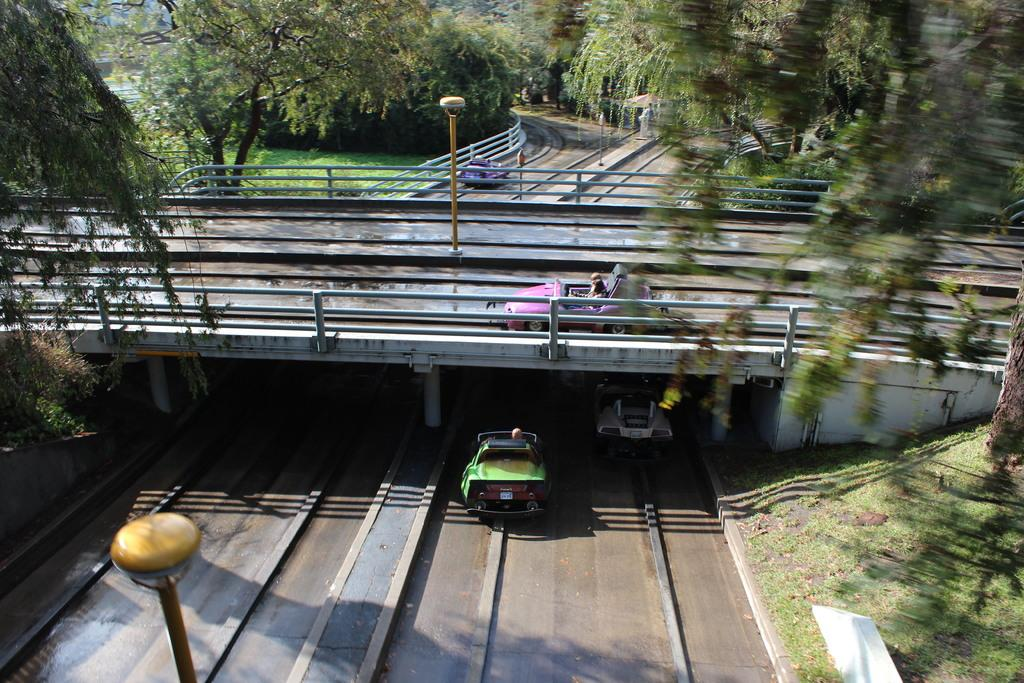What can be seen on the roads in the image? There are vehicles on the roads in the image. What type of structure is present in the image that allows vehicles to cross over a body of water or land? There is a bridge with pillars in the image. What type of vegetation is present in the image? There are many trees in the image. What type of ground cover can be seen in the image? There is grass on the ground in the image. What type of infrastructure is present in the image to provide lighting? There are light poles in the image. Can you see an example of a hose being used to water the trees in the image? There is no hose present in the image; only trees, grass, and light poles are visible. What type of beam is supporting the bridge in the image? The image does not show the specific type of beam supporting the bridge; it only shows the bridge with pillars. 